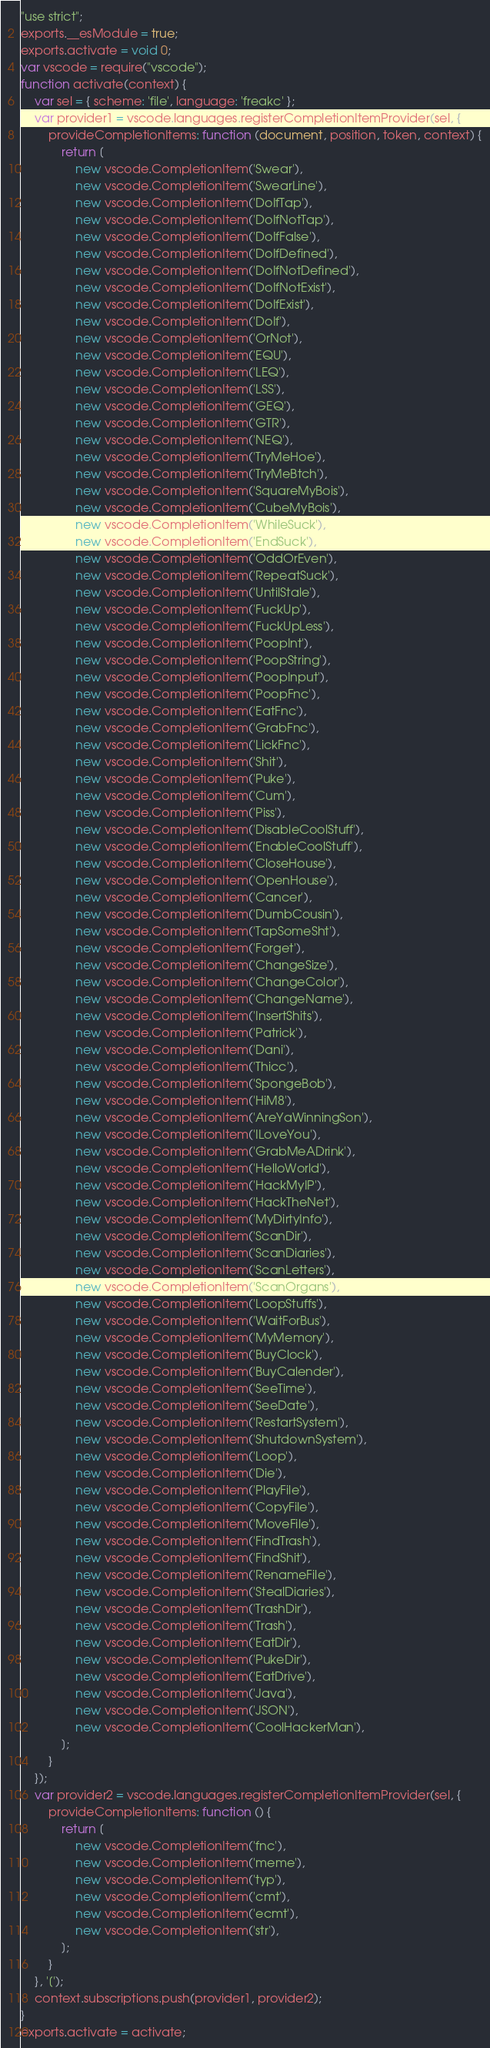Convert code to text. <code><loc_0><loc_0><loc_500><loc_500><_JavaScript_>"use strict";
exports.__esModule = true;
exports.activate = void 0;
var vscode = require("vscode");
function activate(context) {
    var sel = { scheme: 'file', language: 'freakc' };
    var provider1 = vscode.languages.registerCompletionItemProvider(sel, {
        provideCompletionItems: function (document, position, token, context) {
            return [
                new vscode.CompletionItem('Swear'),
                new vscode.CompletionItem('SwearLine'),
                new vscode.CompletionItem('DoIfTap'),
                new vscode.CompletionItem('DoIfNotTap'),
                new vscode.CompletionItem('DoIfFalse'),
                new vscode.CompletionItem('DoIfDefined'),
                new vscode.CompletionItem('DoIfNotDefined'),
                new vscode.CompletionItem('DoIfNotExist'),
                new vscode.CompletionItem('DoIfExist'),
                new vscode.CompletionItem('DoIf'),
                new vscode.CompletionItem('OrNot'),
                new vscode.CompletionItem('EQU'),
                new vscode.CompletionItem('LEQ'),
                new vscode.CompletionItem('LSS'),
                new vscode.CompletionItem('GEQ'),
                new vscode.CompletionItem('GTR'),
                new vscode.CompletionItem('NEQ'),
                new vscode.CompletionItem('TryMeHoe'),
                new vscode.CompletionItem('TryMeBtch'),
                new vscode.CompletionItem('SquareMyBois'),
                new vscode.CompletionItem('CubeMyBois'),
                new vscode.CompletionItem('WhileSuck'),
                new vscode.CompletionItem('EndSuck'),
                new vscode.CompletionItem('OddOrEven'),
                new vscode.CompletionItem('RepeatSuck'),
                new vscode.CompletionItem('UntilStale'),
                new vscode.CompletionItem('FuckUp'),
                new vscode.CompletionItem('FuckUpLess'),
                new vscode.CompletionItem('PoopInt'),
                new vscode.CompletionItem('PoopString'),
                new vscode.CompletionItem('PoopInput'),
                new vscode.CompletionItem('PoopFnc'),
                new vscode.CompletionItem('EatFnc'),
                new vscode.CompletionItem('GrabFnc'),
                new vscode.CompletionItem('LickFnc'),
                new vscode.CompletionItem('Shit'),
                new vscode.CompletionItem('Puke'),
                new vscode.CompletionItem('Cum'),
                new vscode.CompletionItem('Piss'),
                new vscode.CompletionItem('DisableCoolStuff'),
                new vscode.CompletionItem('EnableCoolStuff'),
                new vscode.CompletionItem('CloseHouse'),
                new vscode.CompletionItem('OpenHouse'),
                new vscode.CompletionItem('Cancer'),
                new vscode.CompletionItem('DumbCousin'),
                new vscode.CompletionItem('TapSomeSht'),
                new vscode.CompletionItem('Forget'),
                new vscode.CompletionItem('ChangeSize'),
                new vscode.CompletionItem('ChangeColor'),
                new vscode.CompletionItem('ChangeName'),
                new vscode.CompletionItem('InsertShits'),
                new vscode.CompletionItem('Patrick'),
                new vscode.CompletionItem('Dani'),
                new vscode.CompletionItem('Thicc'),
                new vscode.CompletionItem('SpongeBob'),
                new vscode.CompletionItem('HiM8'),
                new vscode.CompletionItem('AreYaWinningSon'),
                new vscode.CompletionItem('ILoveYou'),
                new vscode.CompletionItem('GrabMeADrink'),
                new vscode.CompletionItem('HelloWorld'),
                new vscode.CompletionItem('HackMyIP'),
                new vscode.CompletionItem('HackTheNet'),
                new vscode.CompletionItem('MyDirtyInfo'),
                new vscode.CompletionItem('ScanDir'),
                new vscode.CompletionItem('ScanDiaries'),
                new vscode.CompletionItem('ScanLetters'),
                new vscode.CompletionItem('ScanOrgans'),
                new vscode.CompletionItem('LoopStuffs'),
                new vscode.CompletionItem('WaitForBus'),
                new vscode.CompletionItem('MyMemory'),
                new vscode.CompletionItem('BuyClock'),
                new vscode.CompletionItem('BuyCalender'),
                new vscode.CompletionItem('SeeTime'),
                new vscode.CompletionItem('SeeDate'),
                new vscode.CompletionItem('RestartSystem'),
                new vscode.CompletionItem('ShutdownSystem'),
                new vscode.CompletionItem('Loop'),
                new vscode.CompletionItem('Die'),
                new vscode.CompletionItem('PlayFile'),
                new vscode.CompletionItem('CopyFile'),
                new vscode.CompletionItem('MoveFile'),
                new vscode.CompletionItem('FindTrash'),
                new vscode.CompletionItem('FindShit'),
                new vscode.CompletionItem('RenameFile'),
                new vscode.CompletionItem('StealDiaries'),
                new vscode.CompletionItem('TrashDir'),
                new vscode.CompletionItem('Trash'),
                new vscode.CompletionItem('EatDir'),
                new vscode.CompletionItem('PukeDir'),
                new vscode.CompletionItem('EatDrive'),
                new vscode.CompletionItem('Java'),
                new vscode.CompletionItem('JSON'),
                new vscode.CompletionItem('CoolHackerMan'),
            ];
        }
    });
    var provider2 = vscode.languages.registerCompletionItemProvider(sel, {
        provideCompletionItems: function () {
            return [
                new vscode.CompletionItem('fnc'),
                new vscode.CompletionItem('meme'),
                new vscode.CompletionItem('typ'),
                new vscode.CompletionItem('cmt'),
                new vscode.CompletionItem('ecmt'),
                new vscode.CompletionItem('str'),
            ];
        }
    }, '[');
    context.subscriptions.push(provider1, provider2);
}
exports.activate = activate;
</code> 